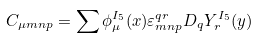Convert formula to latex. <formula><loc_0><loc_0><loc_500><loc_500>C _ { \mu m n p } = \sum \phi _ { \mu } ^ { I _ { 5 } } ( x ) \varepsilon _ { m n p } ^ { q r } D _ { q } Y _ { r } ^ { I _ { 5 } } ( y )</formula> 